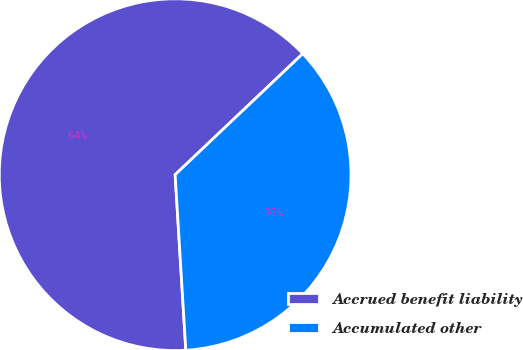Convert chart to OTSL. <chart><loc_0><loc_0><loc_500><loc_500><pie_chart><fcel>Accrued benefit liability<fcel>Accumulated other<nl><fcel>63.89%<fcel>36.11%<nl></chart> 